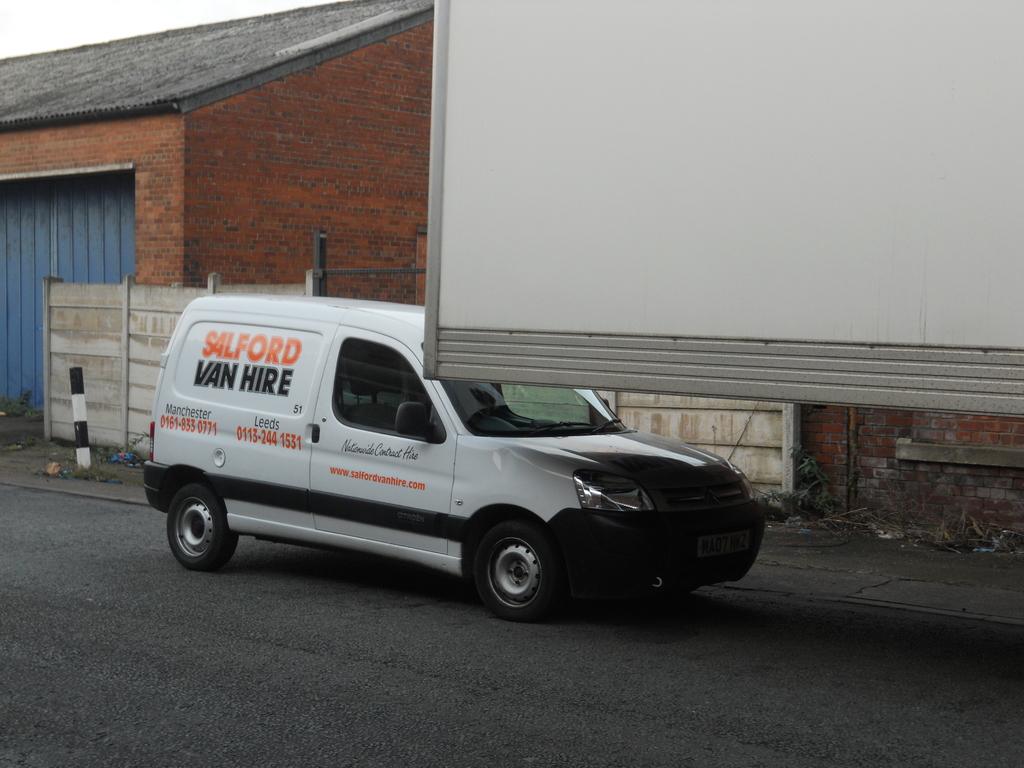What is the company name on the van?
Offer a terse response. Salford van hire. 